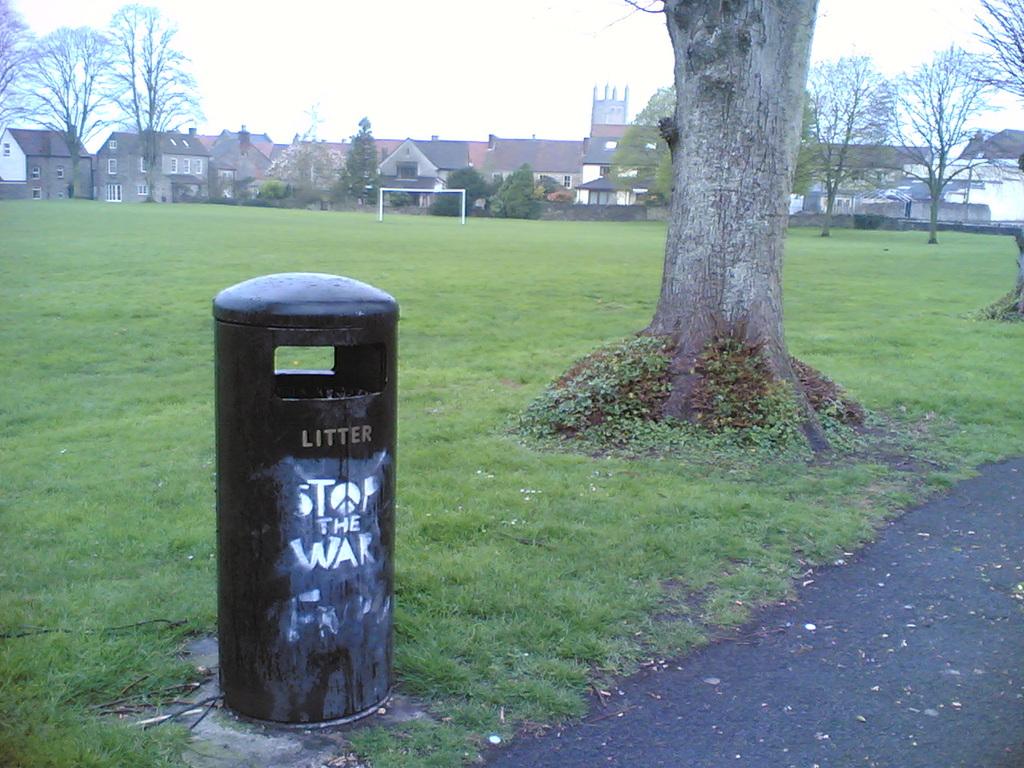What does the litter bin say underneath?
Offer a terse response. Stop the war. What is the first word on the can say?
Offer a terse response. Litter. 